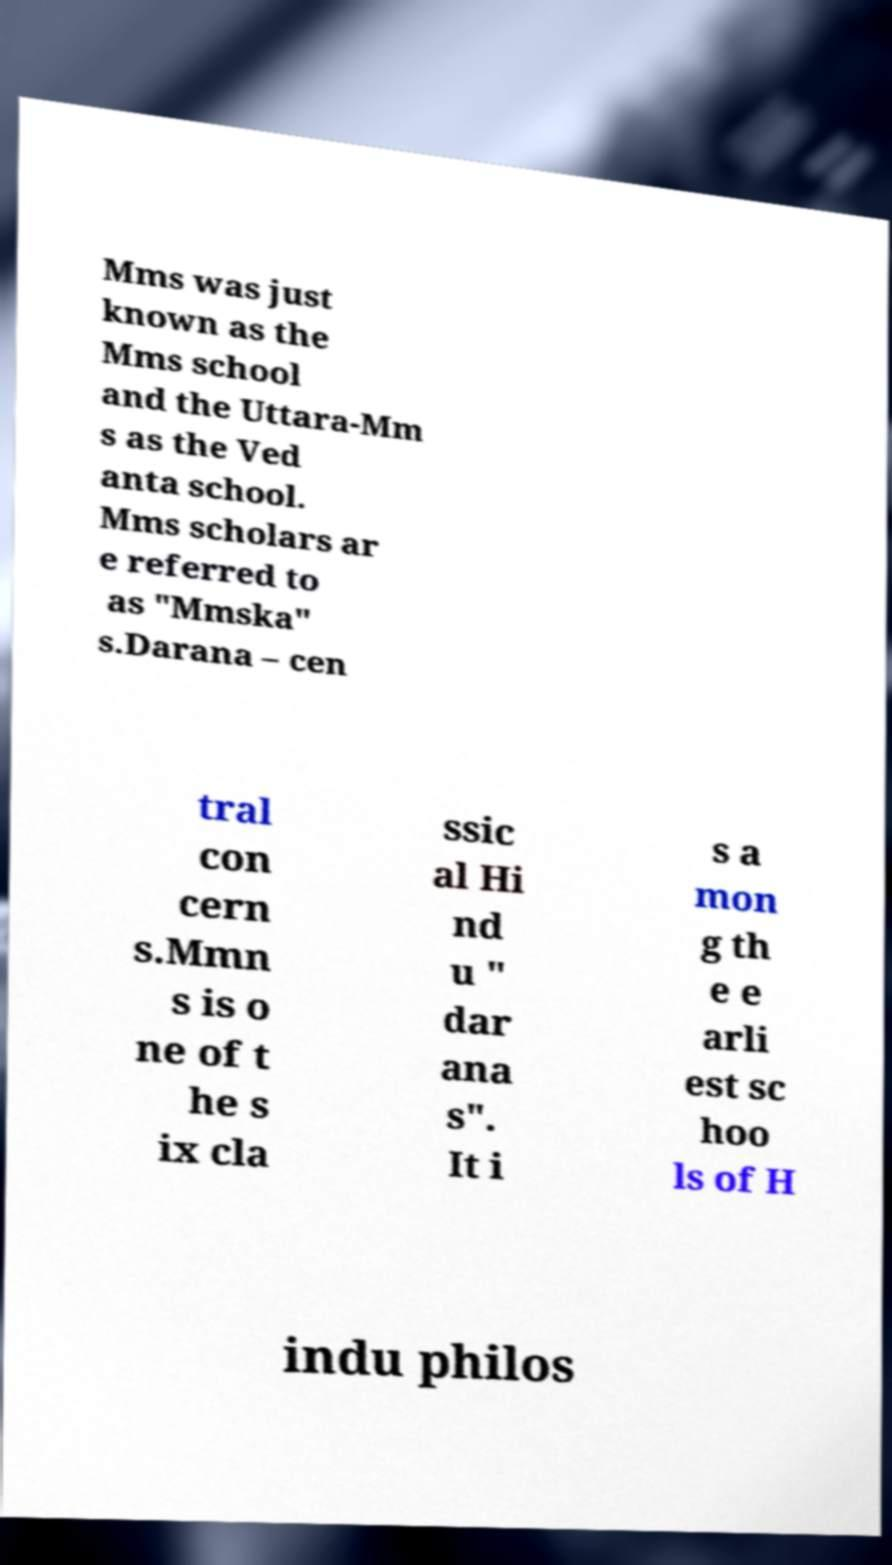Could you assist in decoding the text presented in this image and type it out clearly? Mms was just known as the Mms school and the Uttara-Mm s as the Ved anta school. Mms scholars ar e referred to as "Mmska" s.Darana – cen tral con cern s.Mmn s is o ne of t he s ix cla ssic al Hi nd u " dar ana s". It i s a mon g th e e arli est sc hoo ls of H indu philos 